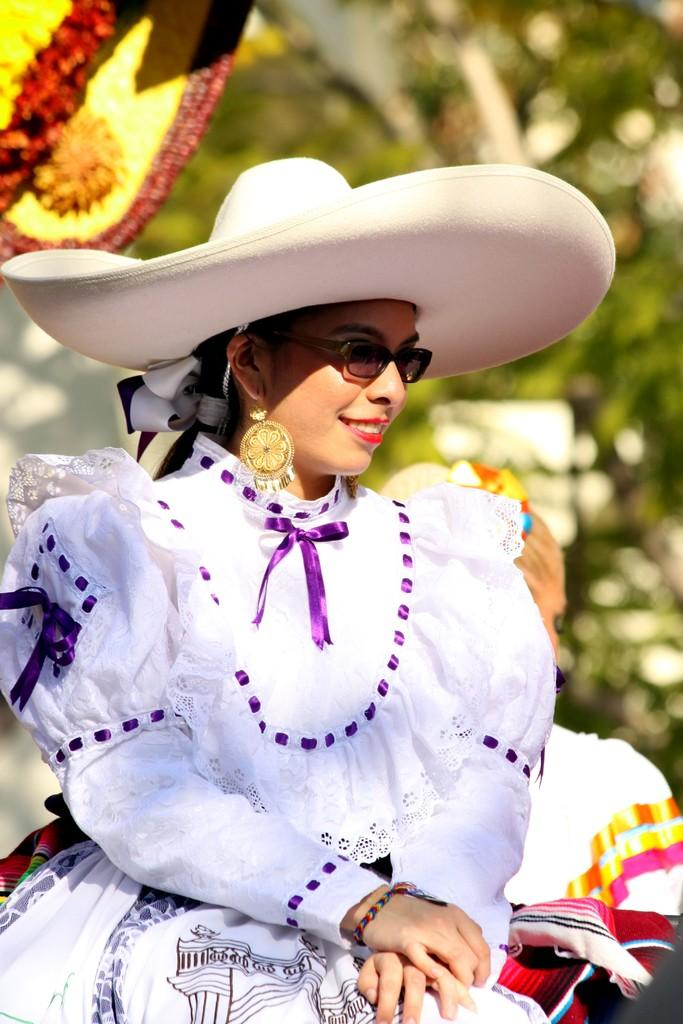Who is the main subject in the image? There is a woman in the center of the image. What is the woman wearing? The woman is wearing a white dress and a white hat. What is the woman's facial expression in the image? The woman is smiling. How would you describe the background of the image? The background of the image is blurry. Can you tell me how many lakes are visible in the background of the image? There are no lakes visible in the background of the image; it is blurry and does not show any specific features. 